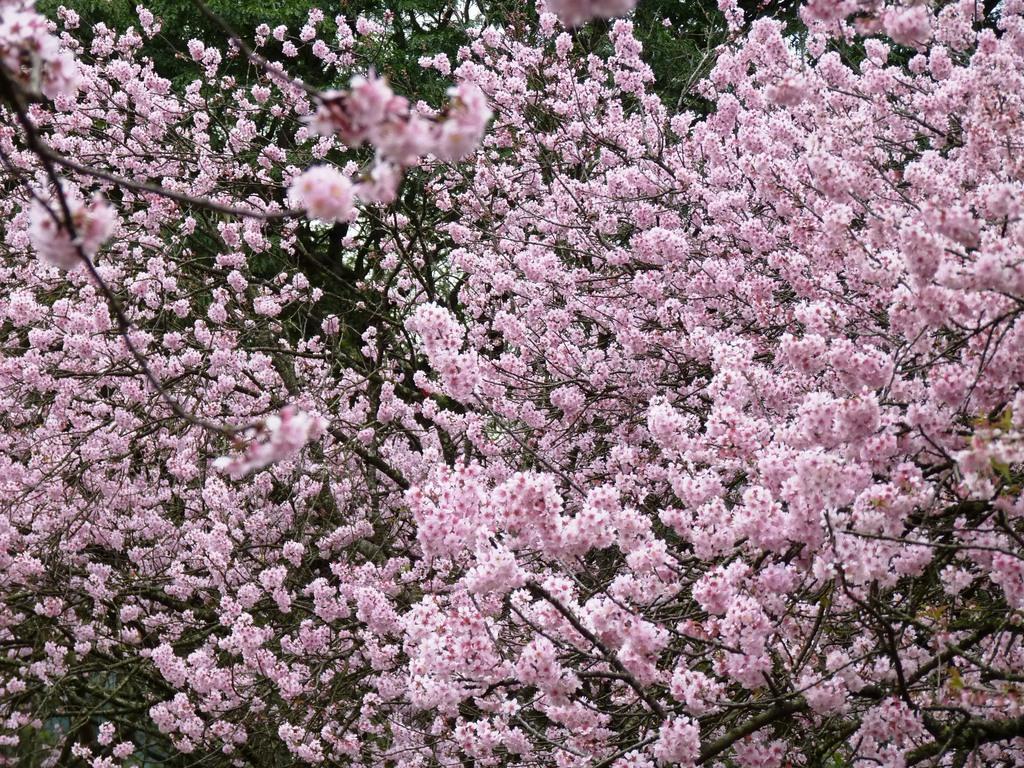Describe this image in one or two sentences. In this image, we can see blossom of flowers. 